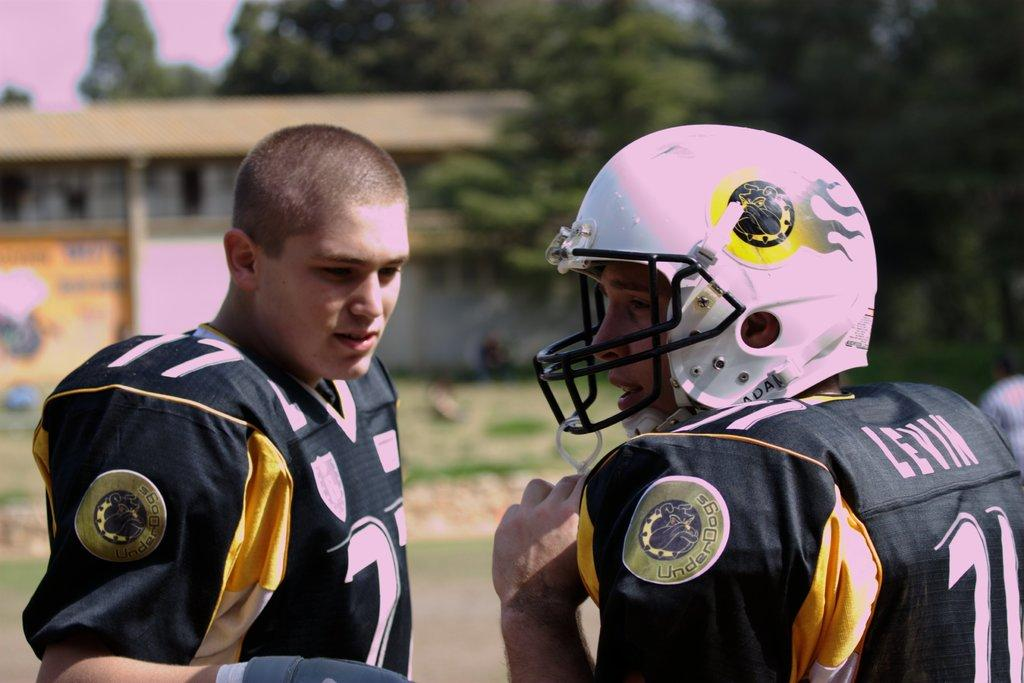How many people are in the image? There are two men in the image. What is one of the men wearing? One of the men is wearing a helmet. What can be seen in the background of the image? There is a house, trees, and the sky visible in the background of the image. What type of insurance policy is the man with the helmet discussing in the image? There is no indication in the image that the men are discussing insurance or any other topic. 